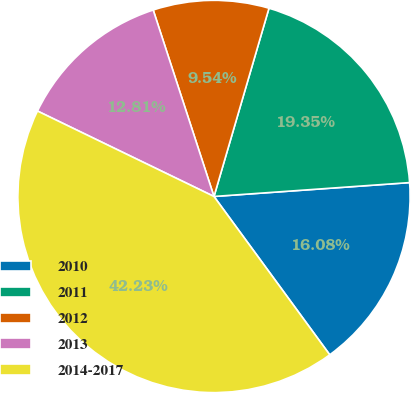Convert chart to OTSL. <chart><loc_0><loc_0><loc_500><loc_500><pie_chart><fcel>2010<fcel>2011<fcel>2012<fcel>2013<fcel>2014-2017<nl><fcel>16.08%<fcel>19.35%<fcel>9.54%<fcel>12.81%<fcel>42.23%<nl></chart> 